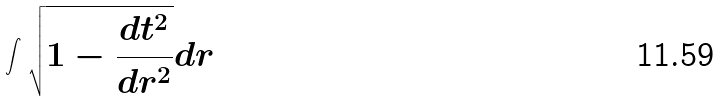Convert formula to latex. <formula><loc_0><loc_0><loc_500><loc_500>\int \sqrt { 1 - \frac { d t ^ { 2 } } { d r ^ { 2 } } } d r</formula> 